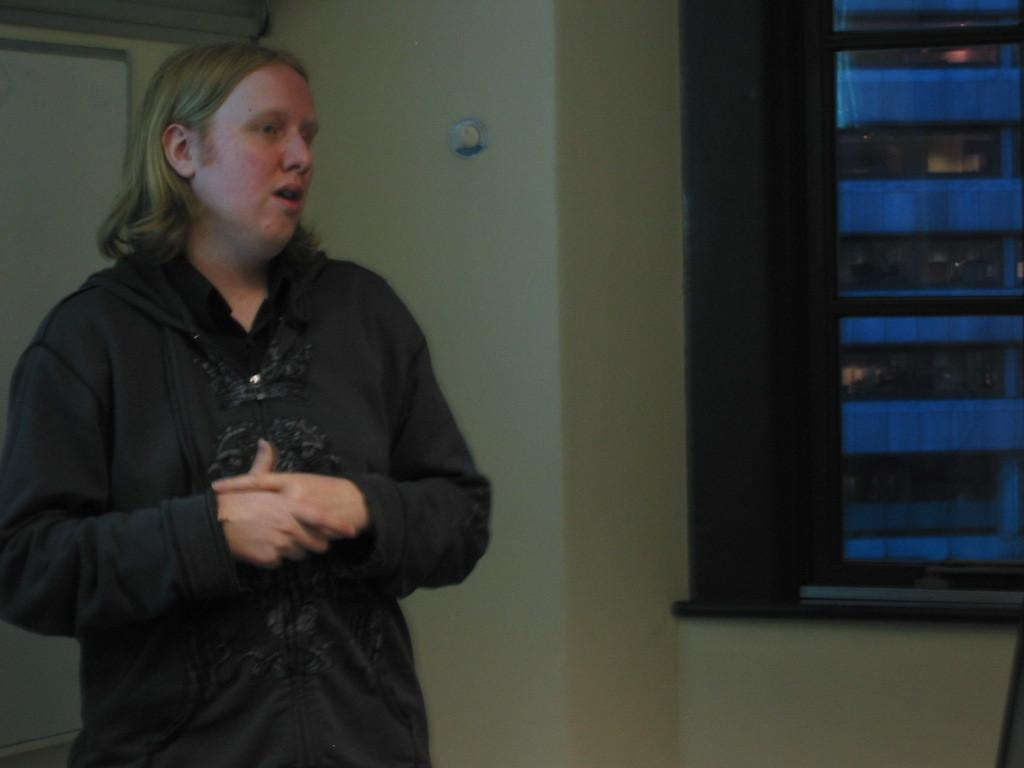Who or what is present on the left side of the image? There is a person on the left side of the image. Can you describe the background of the image? There is a wall in the background of the image. What is the profit margin of the playground in the image? There is no playground present in the image, so it is not possible to determine the profit margin. 